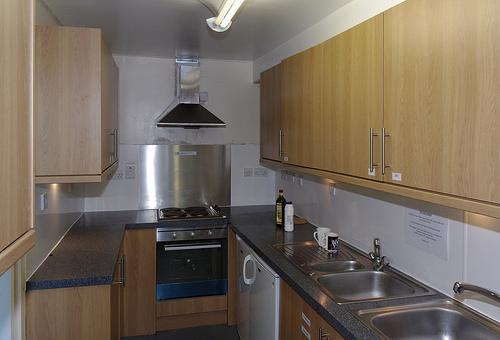Mention three objects related to cooking or food preparation that can be seen in the image. An oven, a stove with four burners, and kitchen spices can be seen in the image. State the number of handles and their locations in the kitchen scene. There are three handles: silver handle on cupboard, handle on the dishwasher, and handle to kitchen cabinets. Identify an object in the image that can help in maintaining a clean kitchen environment. The exhaust hood above the stove helps in maintaining a clean kitchen environment. How many coffee mugs can be identified in the image? There are two coffee mugs in the image. Describe the color and material of the kitchen sink. The kitchen sink is silver in color and made of stainless steel. Give a brief description of the light source in the image. There is a light fixture on the ceiling, which appears to be the main light source in the image. Describe a sentimental aspect that can be attributed to the image. The note on the wall of the kitchen can be seen as a sentimental aspect, as it might reflect communication or a personal message from a family member or a roommate. Identify the main theme of the image and provide a brief description. The image features a kitchen scene with various objects like cabinets, a sink, an oven, stove, and various kitchen items on the counter. Is there any non-traditional or unexpected item in the kitchen scene? Yes, there is a piece of paper with writing attached to the wall in the kitchen. Observe the cat on the kitchen floor with the following info - X:100 Y:350 Width:30 Height:30. Would you say the cat appears to be comfortable in the kitchen? No cat is listed among the objects in the image, but by providing coordinates and size, someone might attempt to find the cat in the image. Regarding the red kettle at X:40 Y:250 Width:20 Height:20, is it on the stove or on the counter? There is no red kettle mentioned in the list of objects. By providing made-up size and coordinates, it might confuse someone to think it's in the image. Take a look at the potted plant near the window. Its position is X:450 Y:30 Width:20 Height:20. Do you think the plant is receiving enough sunlight? There is no mention of a potted plant or a window in the list of objects. By providing coordinates and size, it could lead someone to think the plant is in the scene. Concerning the blue dish towel hanging from the oven door, its attributes are X:170 Y:270 Width:10 Height:25. Does the towel match with the color scheme of the kitchen? There is no mention of a dish towel in the list of objects, and by providing made-up coordinates and size, the instruction could lead someone to search for the towel in the image. Please locate the yellow toaster on the counter with these parameters - X:320 Y:220 Width:25 Height:25. Is it next to the coffee mugs? A yellow toaster is not among the listed objects. By providing made-up object's position and size, someone might spend time looking for the non-existent toaster in the image. Please examine the green apple sitting on the counter, its X:190 Y:290 Width:12 Height:12. Is the apple ripe or not? There is no mention of a green apple in the given object list, and providing the made-up coordinates and size might make someone think it's actually in the image. 